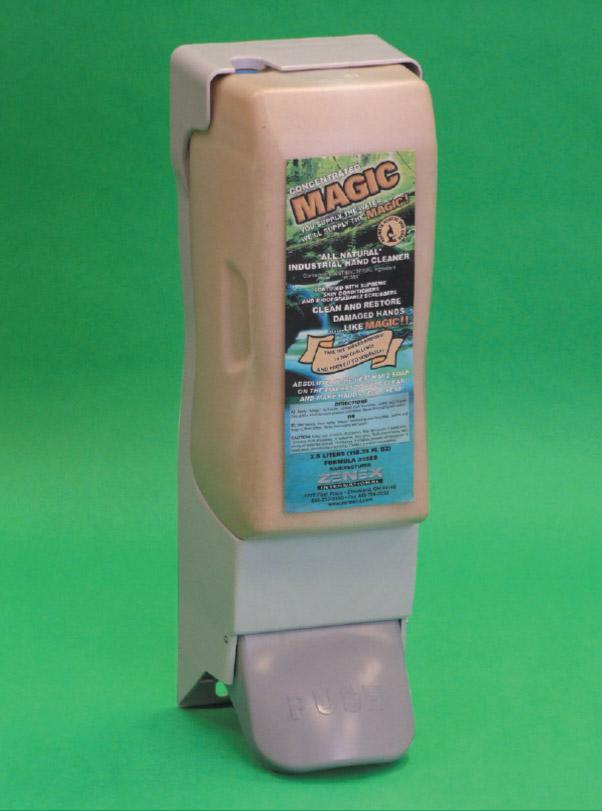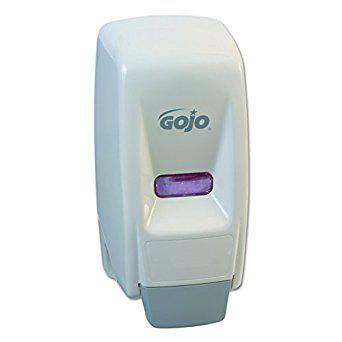The first image is the image on the left, the second image is the image on the right. Assess this claim about the two images: "One soap container is brown.". Correct or not? Answer yes or no. Yes. The first image is the image on the left, the second image is the image on the right. Assess this claim about the two images: "The left and right image contains the same number of full wall hanging soap dispensers.". Correct or not? Answer yes or no. Yes. 